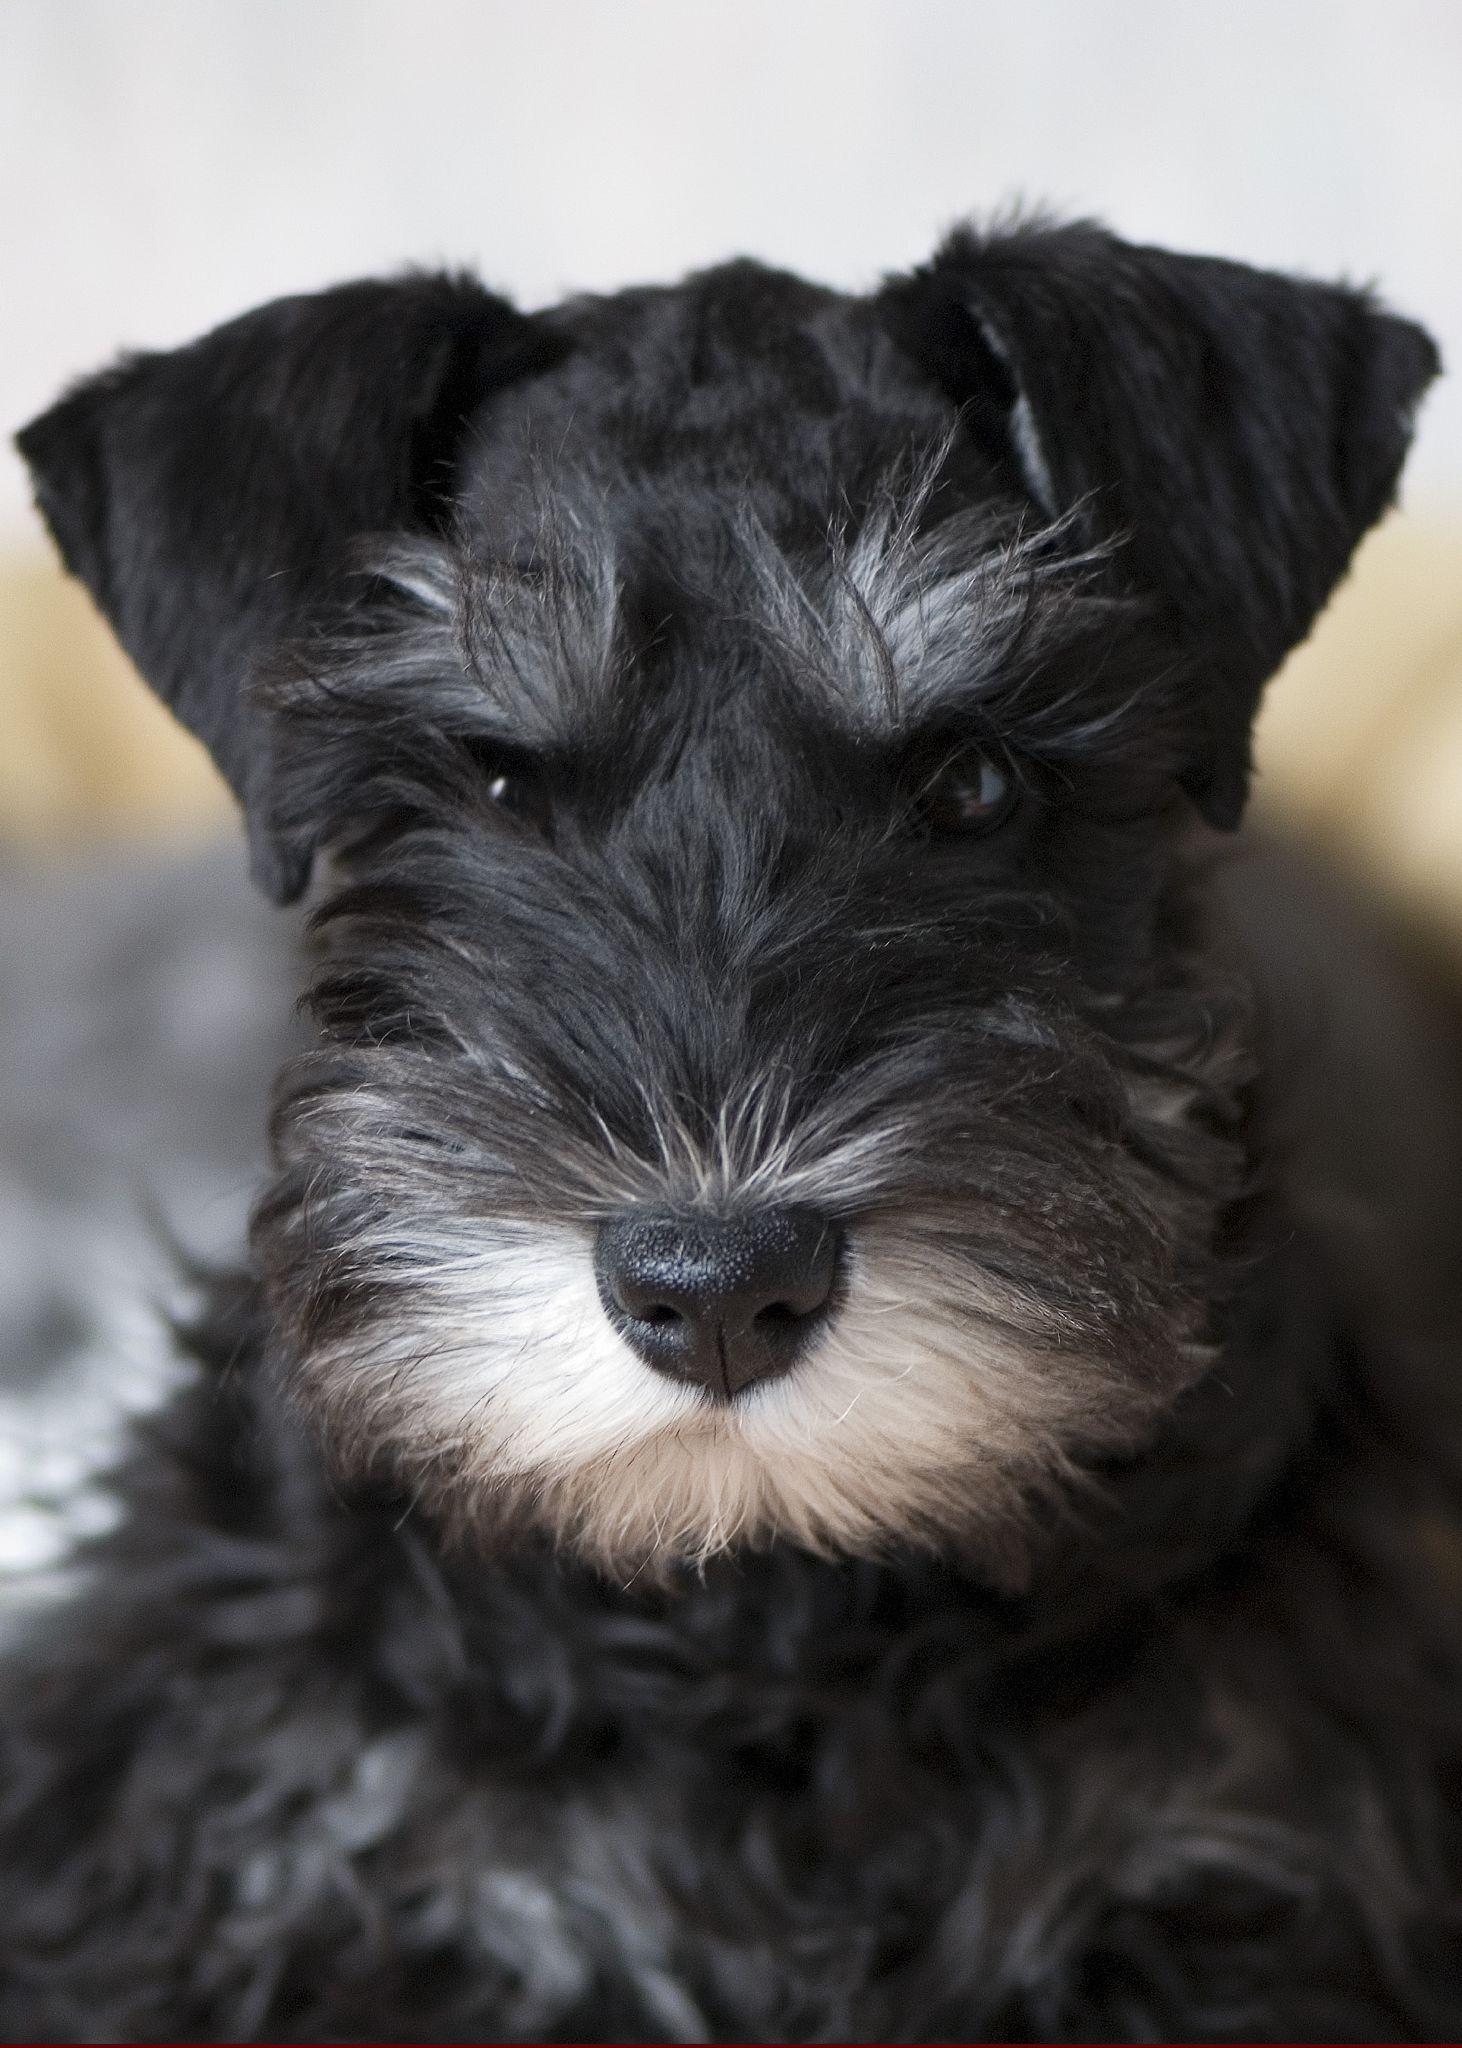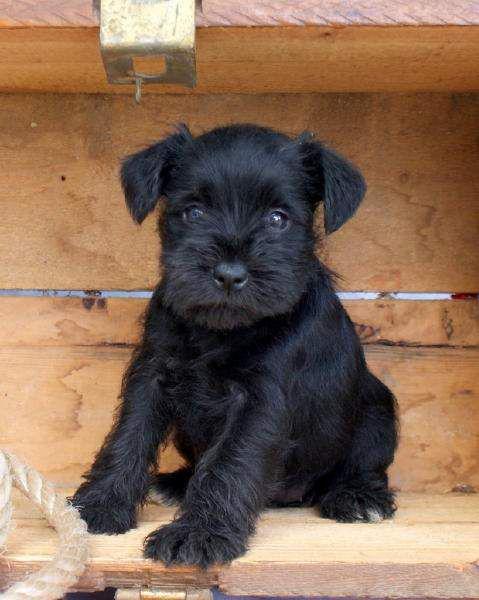The first image is the image on the left, the second image is the image on the right. Given the left and right images, does the statement "Each image contains a camera-facing schnauzer with a solid-black face, and no image shows a dog in a reclining pose." hold true? Answer yes or no. No. The first image is the image on the left, the second image is the image on the right. Analyze the images presented: Is the assertion "The puppy on the right has a white streak on its chest." valid? Answer yes or no. No. 